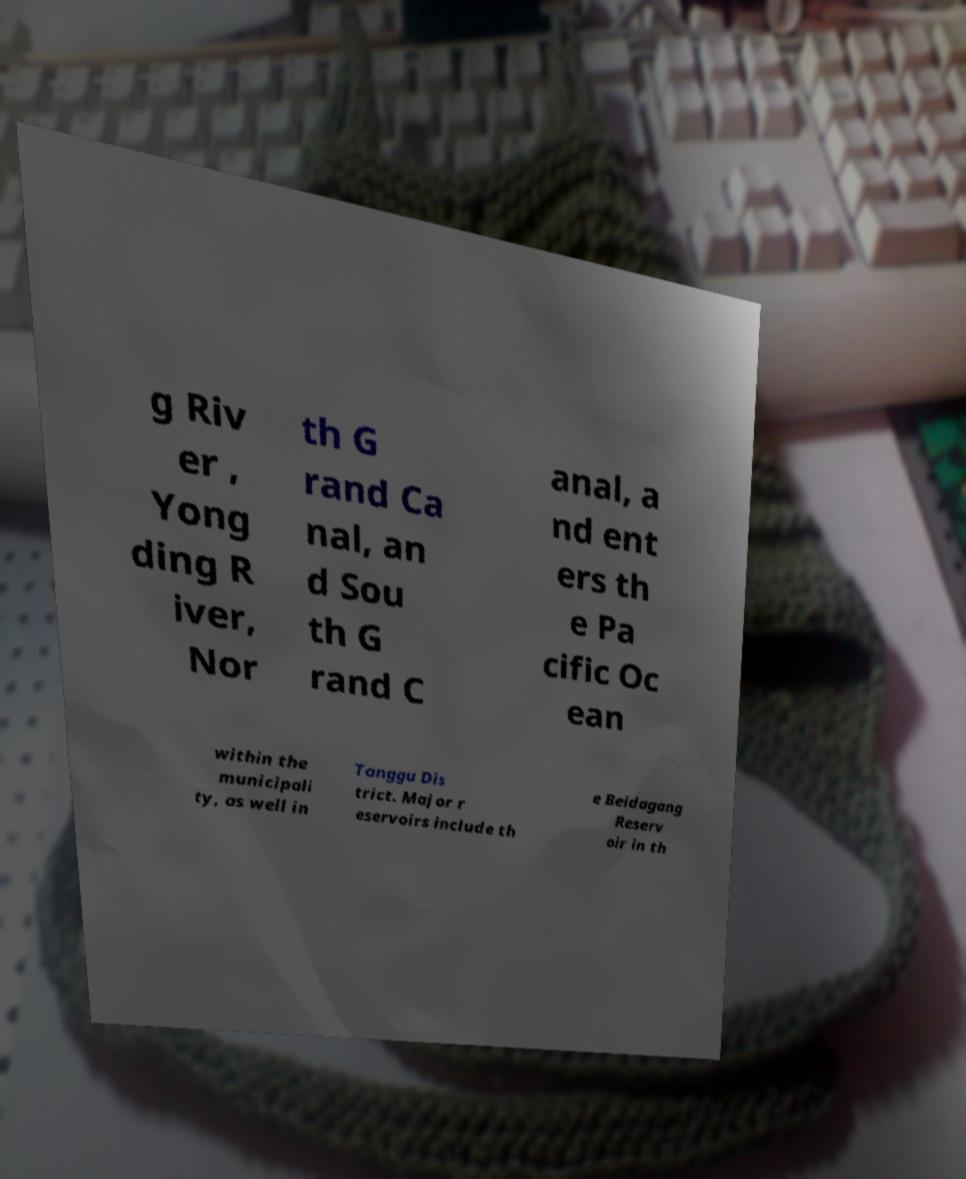What messages or text are displayed in this image? I need them in a readable, typed format. g Riv er , Yong ding R iver, Nor th G rand Ca nal, an d Sou th G rand C anal, a nd ent ers th e Pa cific Oc ean within the municipali ty, as well in Tanggu Dis trict. Major r eservoirs include th e Beidagang Reserv oir in th 